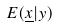Convert formula to latex. <formula><loc_0><loc_0><loc_500><loc_500>E ( \underline { x } | y )</formula> 